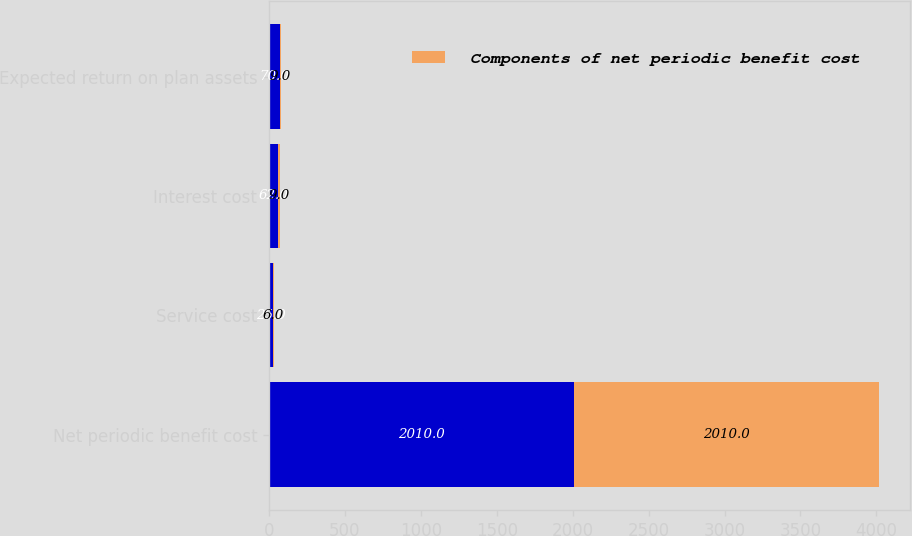<chart> <loc_0><loc_0><loc_500><loc_500><stacked_bar_chart><ecel><fcel>Net periodic benefit cost<fcel>Service cost<fcel>Interest cost<fcel>Expected return on plan assets<nl><fcel>nan<fcel>2010<fcel>25<fcel>62<fcel>70<nl><fcel>Components of net periodic benefit cost<fcel>2010<fcel>6<fcel>9<fcel>9<nl></chart> 